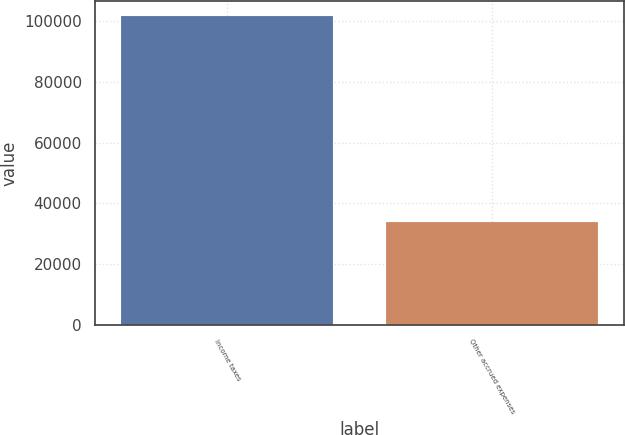Convert chart to OTSL. <chart><loc_0><loc_0><loc_500><loc_500><bar_chart><fcel>Income taxes<fcel>Other accrued expenses<nl><fcel>101406<fcel>33747<nl></chart> 